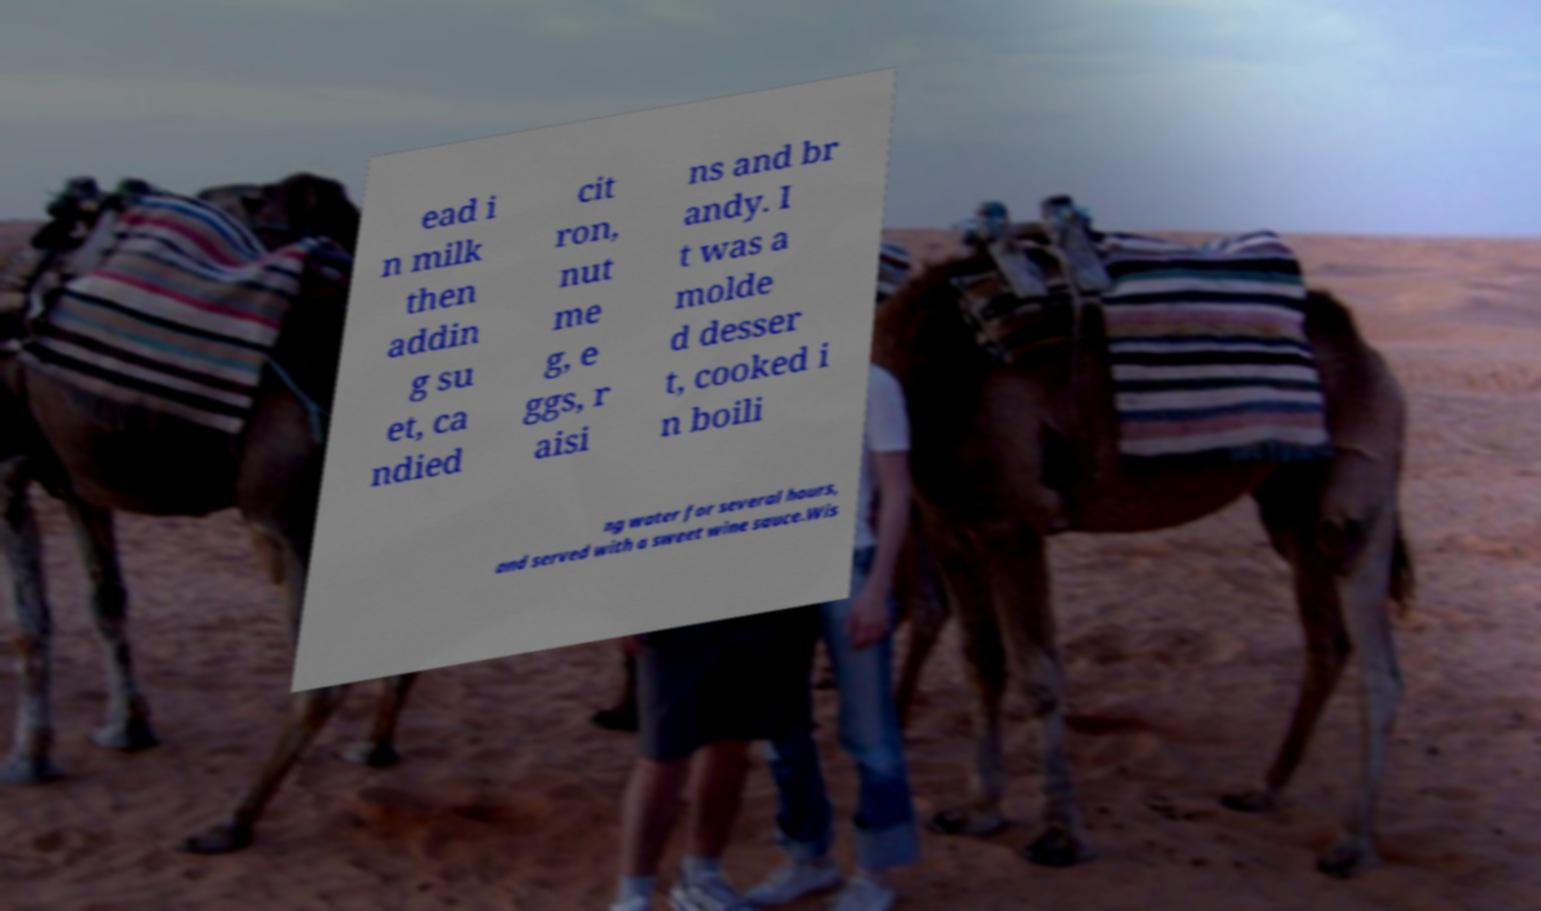Please read and relay the text visible in this image. What does it say? ead i n milk then addin g su et, ca ndied cit ron, nut me g, e ggs, r aisi ns and br andy. I t was a molde d desser t, cooked i n boili ng water for several hours, and served with a sweet wine sauce.Wis 